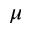<formula> <loc_0><loc_0><loc_500><loc_500>\mu</formula> 